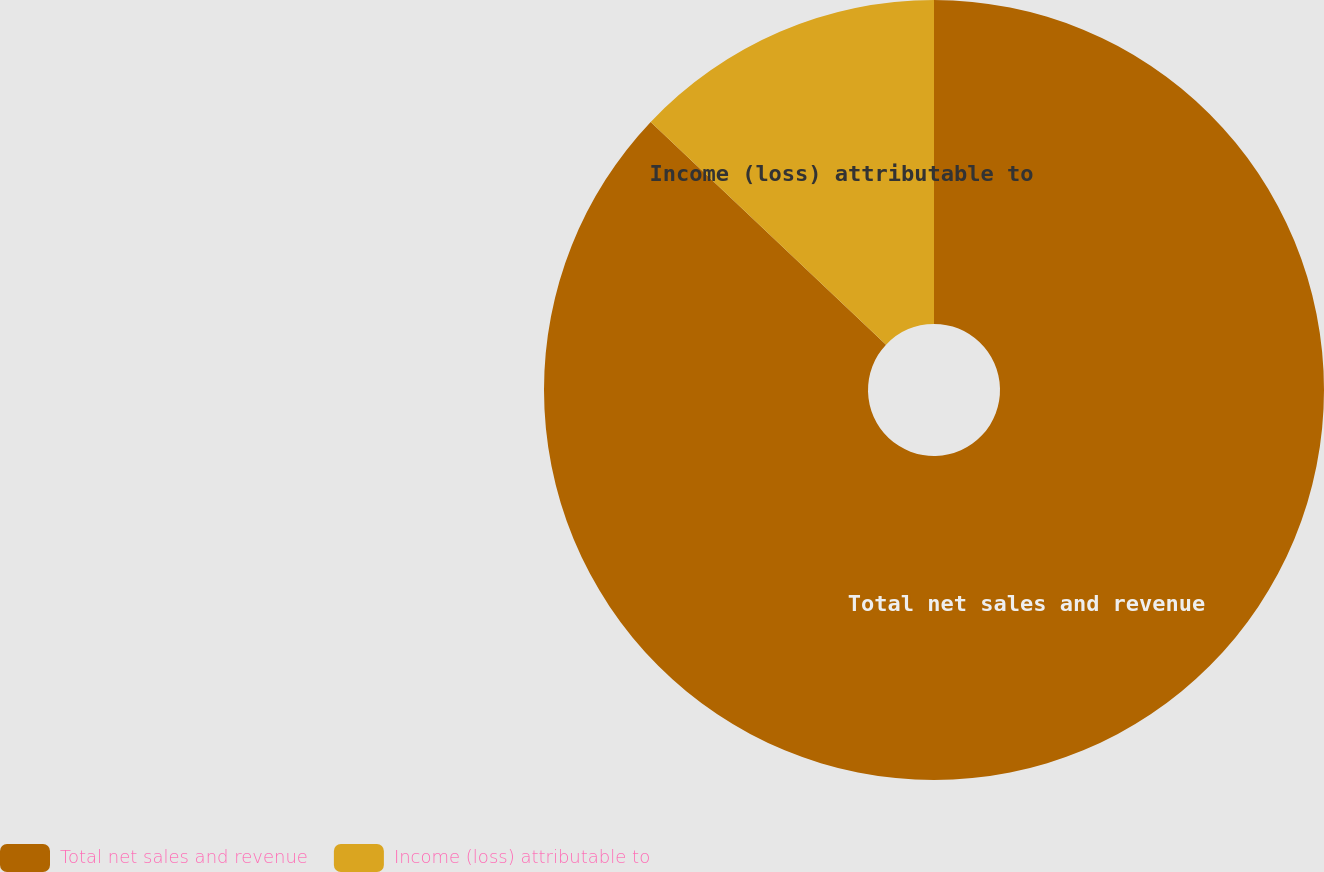<chart> <loc_0><loc_0><loc_500><loc_500><pie_chart><fcel>Total net sales and revenue<fcel>Income (loss) attributable to<nl><fcel>87.06%<fcel>12.94%<nl></chart> 